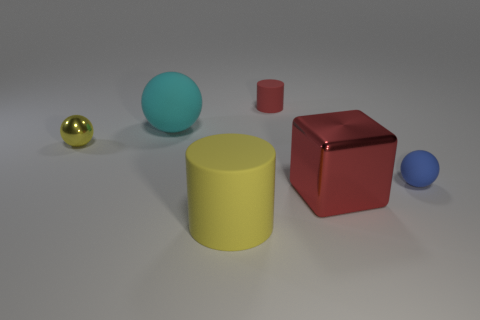If this image were part of a visual arts learning module, what lesson could it be teaching? This image could serve as a learning resource in a module on the fundamentals of 3D modeling and rendering. It illustrates basic geometric shapes, the effects of lighting on objects, and the use of perspective. Additionally, it could demonstrate the concepts of materials and textures, as each object appears to have a unique surface that interacts with light differently. 